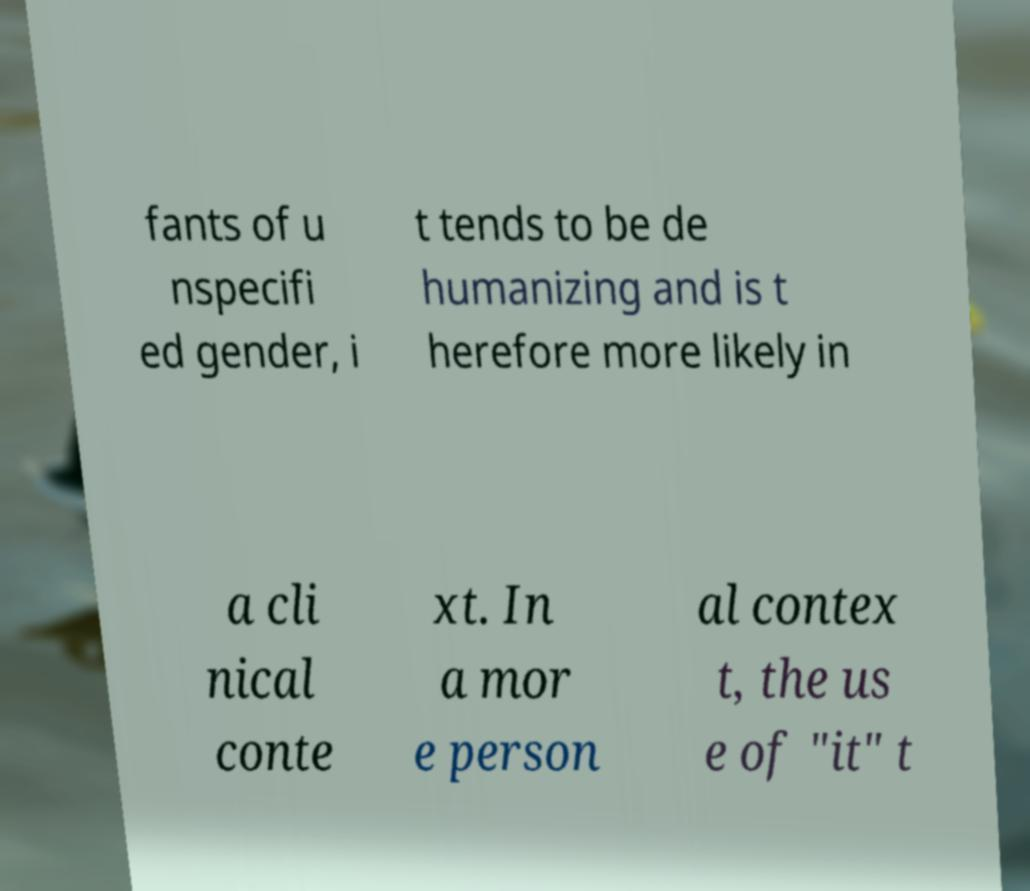Please identify and transcribe the text found in this image. fants of u nspecifi ed gender, i t tends to be de humanizing and is t herefore more likely in a cli nical conte xt. In a mor e person al contex t, the us e of "it" t 